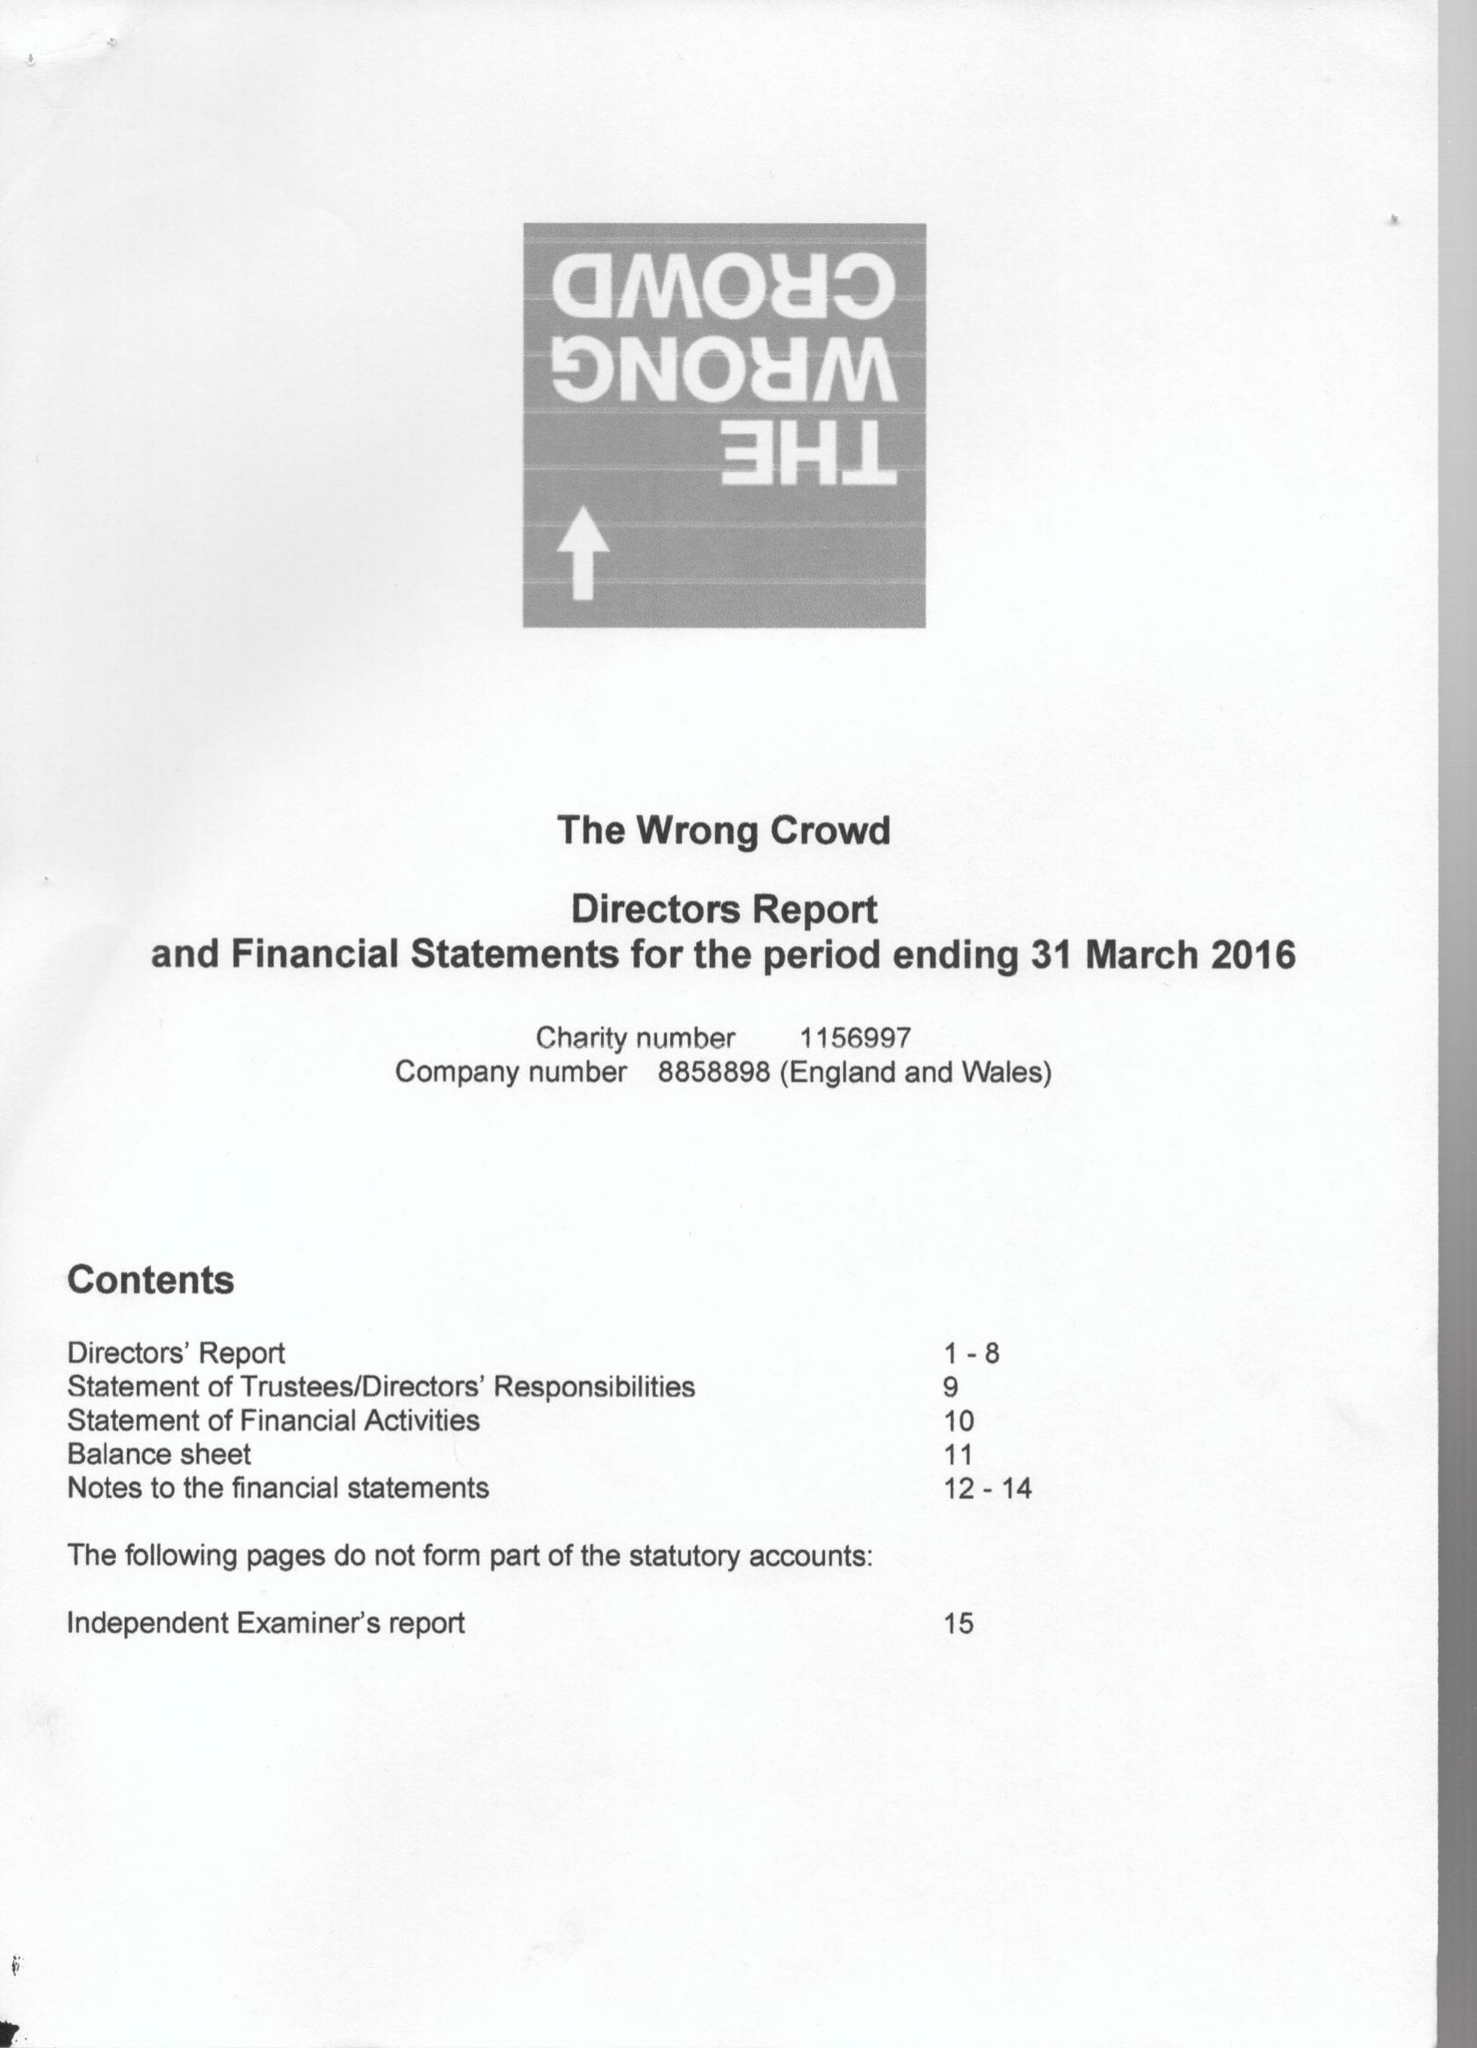What is the value for the charity_number?
Answer the question using a single word or phrase. 1156997 